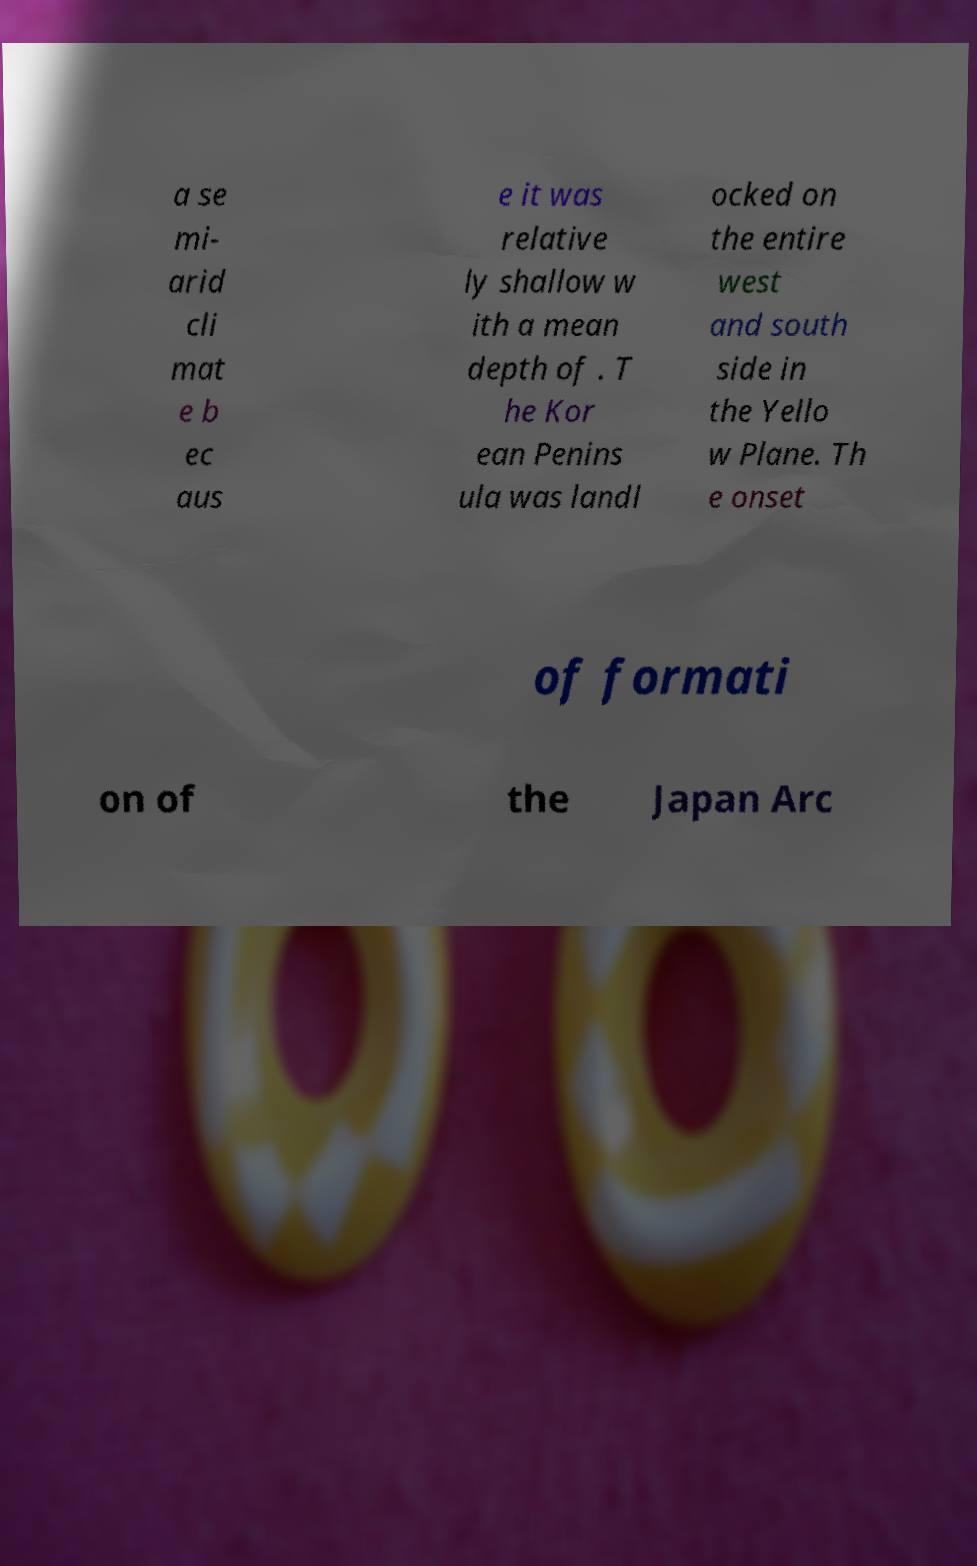I need the written content from this picture converted into text. Can you do that? a se mi- arid cli mat e b ec aus e it was relative ly shallow w ith a mean depth of . T he Kor ean Penins ula was landl ocked on the entire west and south side in the Yello w Plane. Th e onset of formati on of the Japan Arc 